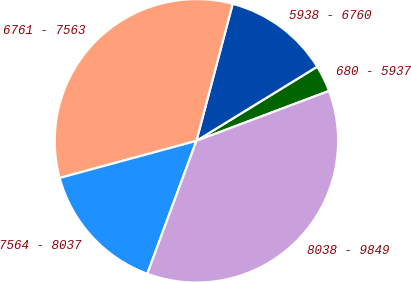<chart> <loc_0><loc_0><loc_500><loc_500><pie_chart><fcel>680 - 5937<fcel>5938 - 6760<fcel>6761 - 7563<fcel>7564 - 8037<fcel>8038 - 9849<nl><fcel>3.03%<fcel>12.12%<fcel>33.33%<fcel>15.15%<fcel>36.36%<nl></chart> 